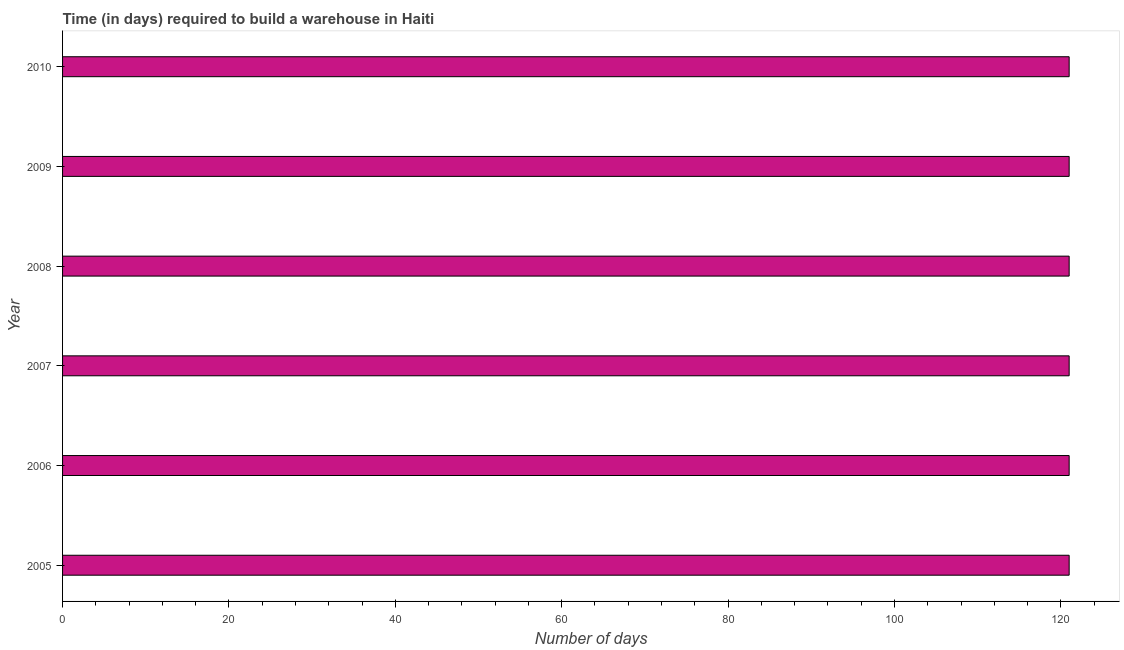Does the graph contain grids?
Provide a succinct answer. No. What is the title of the graph?
Offer a terse response. Time (in days) required to build a warehouse in Haiti. What is the label or title of the X-axis?
Offer a terse response. Number of days. What is the time required to build a warehouse in 2008?
Offer a very short reply. 121. Across all years, what is the maximum time required to build a warehouse?
Provide a succinct answer. 121. Across all years, what is the minimum time required to build a warehouse?
Your response must be concise. 121. In which year was the time required to build a warehouse minimum?
Keep it short and to the point. 2005. What is the sum of the time required to build a warehouse?
Your answer should be compact. 726. What is the difference between the time required to build a warehouse in 2007 and 2008?
Your answer should be very brief. 0. What is the average time required to build a warehouse per year?
Your answer should be compact. 121. What is the median time required to build a warehouse?
Offer a very short reply. 121. In how many years, is the time required to build a warehouse greater than 24 days?
Keep it short and to the point. 6. Do a majority of the years between 2007 and 2005 (inclusive) have time required to build a warehouse greater than 12 days?
Offer a terse response. Yes. What is the difference between the highest and the second highest time required to build a warehouse?
Ensure brevity in your answer.  0. How many years are there in the graph?
Offer a very short reply. 6. Are the values on the major ticks of X-axis written in scientific E-notation?
Your answer should be very brief. No. What is the Number of days in 2005?
Provide a succinct answer. 121. What is the Number of days in 2006?
Your answer should be compact. 121. What is the Number of days in 2007?
Your response must be concise. 121. What is the Number of days in 2008?
Your answer should be compact. 121. What is the Number of days of 2009?
Your answer should be very brief. 121. What is the Number of days in 2010?
Keep it short and to the point. 121. What is the difference between the Number of days in 2005 and 2007?
Ensure brevity in your answer.  0. What is the difference between the Number of days in 2005 and 2008?
Make the answer very short. 0. What is the difference between the Number of days in 2006 and 2008?
Keep it short and to the point. 0. What is the difference between the Number of days in 2007 and 2008?
Your answer should be very brief. 0. What is the difference between the Number of days in 2007 and 2009?
Your answer should be very brief. 0. What is the difference between the Number of days in 2007 and 2010?
Make the answer very short. 0. What is the difference between the Number of days in 2009 and 2010?
Provide a short and direct response. 0. What is the ratio of the Number of days in 2006 to that in 2008?
Offer a terse response. 1. What is the ratio of the Number of days in 2007 to that in 2008?
Provide a short and direct response. 1. What is the ratio of the Number of days in 2007 to that in 2010?
Your answer should be very brief. 1. 